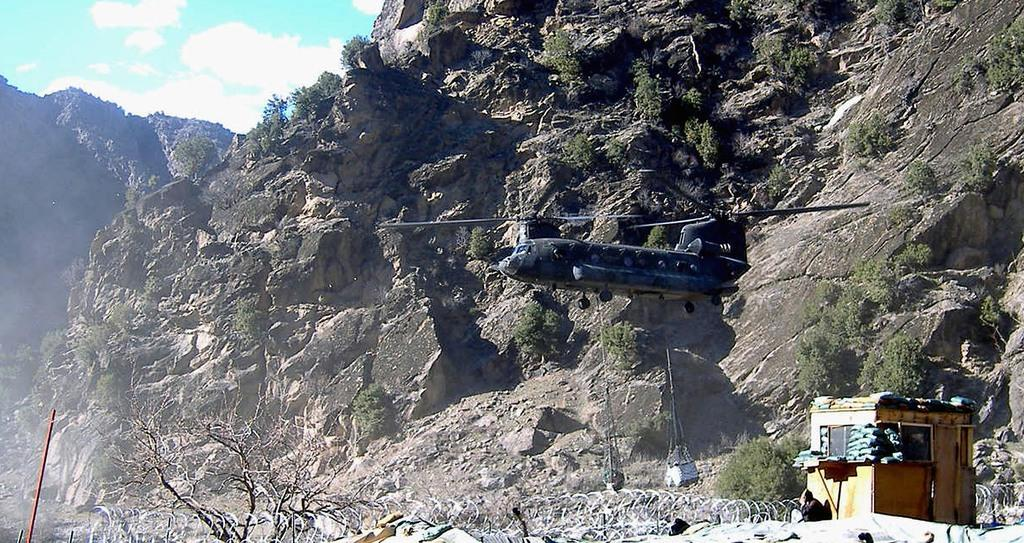What is the main geographical feature in the image? There is a mountain in the image. What is located in front of the mountain? There is an aircraft in front of the mountain. What can be seen on the right side of the image? There appears to be a room on the right side of the image. Who or what is in front of the room? There is a person in front of the room. How many kittens are playing on the person's face in the image? There are no kittens present in the image, and the person's face is not visible. 